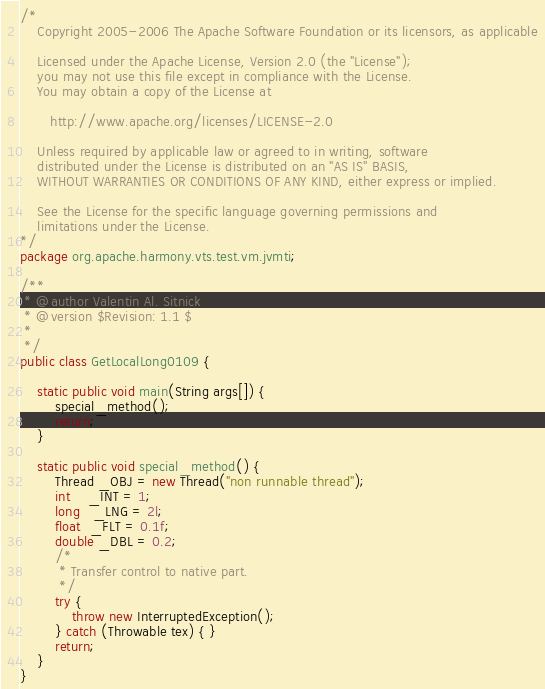Convert code to text. <code><loc_0><loc_0><loc_500><loc_500><_Java_>/*
    Copyright 2005-2006 The Apache Software Foundation or its licensors, as applicable

    Licensed under the Apache License, Version 2.0 (the "License");
    you may not use this file except in compliance with the License.
    You may obtain a copy of the License at

       http://www.apache.org/licenses/LICENSE-2.0

    Unless required by applicable law or agreed to in writing, software
    distributed under the License is distributed on an "AS IS" BASIS,
    WITHOUT WARRANTIES OR CONDITIONS OF ANY KIND, either express or implied.

    See the License for the specific language governing permissions and
    limitations under the License.
*/
package org.apache.harmony.vts.test.vm.jvmti;

/** 
 * @author Valentin Al. Sitnick
 * @version $Revision: 1.1 $
 *
 */ 
public class GetLocalLong0109 {

    static public void main(String args[]) {
        special_method();
        return;
    }

    static public void special_method() {        
        Thread _OBJ = new Thread("non runnable thread");
        int    _INT = 1;
        long   _LNG = 2l;
        float  _FLT = 0.1f;
        double _DBL = 0.2;
        /*
         * Transfer control to native part.
         */
        try {
            throw new InterruptedException();
        } catch (Throwable tex) { }
        return;
    }
}


</code> 